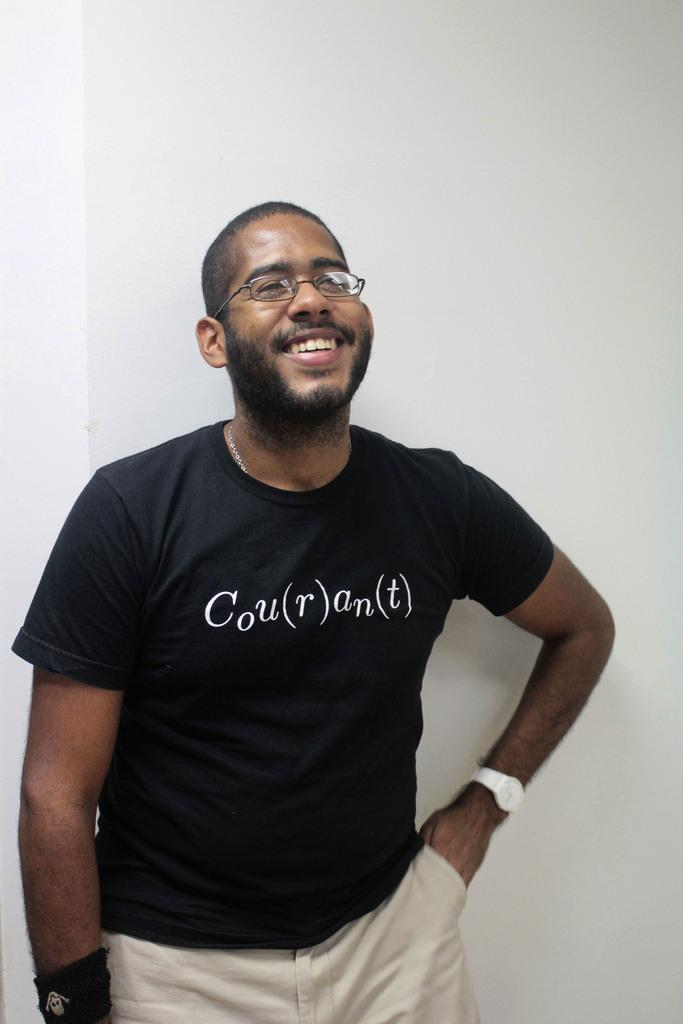Who is present in the image? There is a man in the picture. What type of clothing is the man wearing on his upper body? The man is wearing a t-shirt. What accessory is the man wearing on his face? The man is wearing spectacles. What accessory is the man wearing on his wrist? The man is wearing a watch. What color is the man's underwear in the image? There is no information about the man's underwear in the image, so we cannot determine its color. 